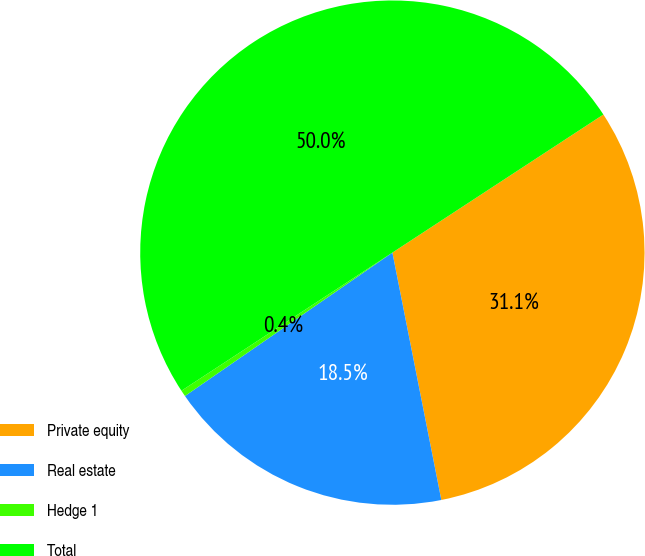Convert chart to OTSL. <chart><loc_0><loc_0><loc_500><loc_500><pie_chart><fcel>Private equity<fcel>Real estate<fcel>Hedge 1<fcel>Total<nl><fcel>31.11%<fcel>18.48%<fcel>0.4%<fcel>50.0%<nl></chart> 